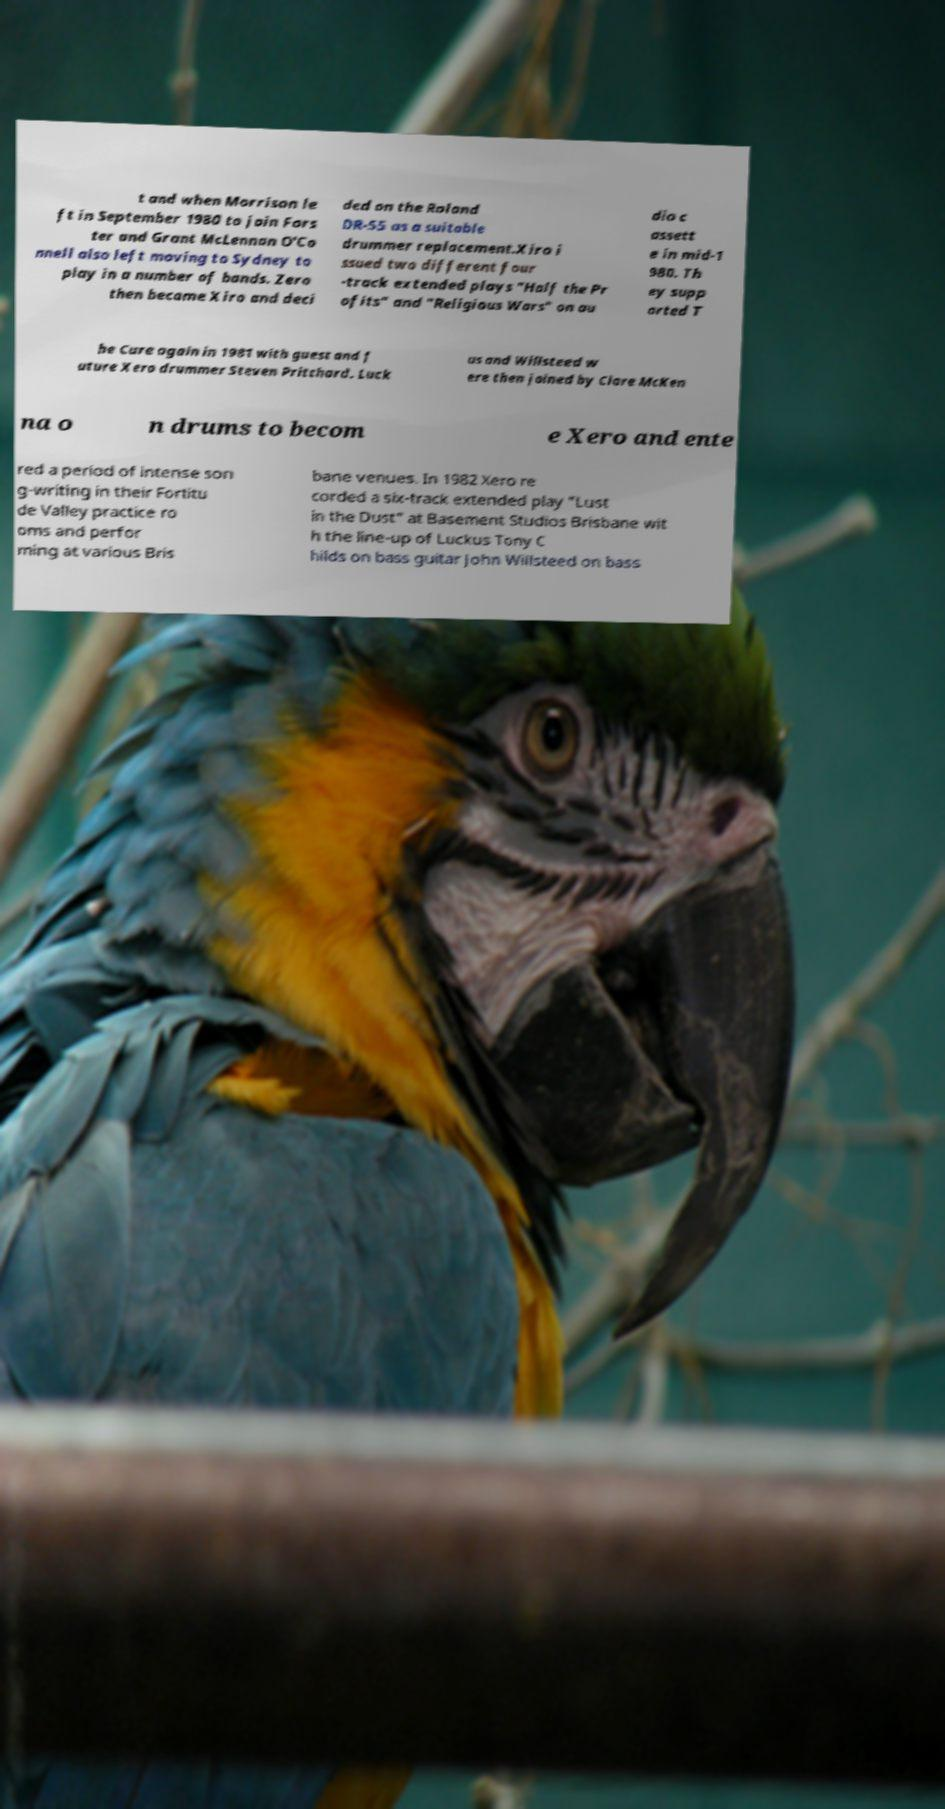For documentation purposes, I need the text within this image transcribed. Could you provide that? t and when Morrison le ft in September 1980 to join Fors ter and Grant McLennan O'Co nnell also left moving to Sydney to play in a number of bands. Zero then became Xiro and deci ded on the Roland DR-55 as a suitable drummer replacement.Xiro i ssued two different four -track extended plays "Half the Pr ofits" and "Religious Wars" on au dio c assett e in mid-1 980. Th ey supp orted T he Cure again in 1981 with guest and f uture Xero drummer Steven Pritchard. Luck us and Willsteed w ere then joined by Clare McKen na o n drums to becom e Xero and ente red a period of intense son g-writing in their Fortitu de Valley practice ro oms and perfor ming at various Bris bane venues. In 1982 Xero re corded a six-track extended play "Lust in the Dust" at Basement Studios Brisbane wit h the line-up of Luckus Tony C hilds on bass guitar John Willsteed on bass 